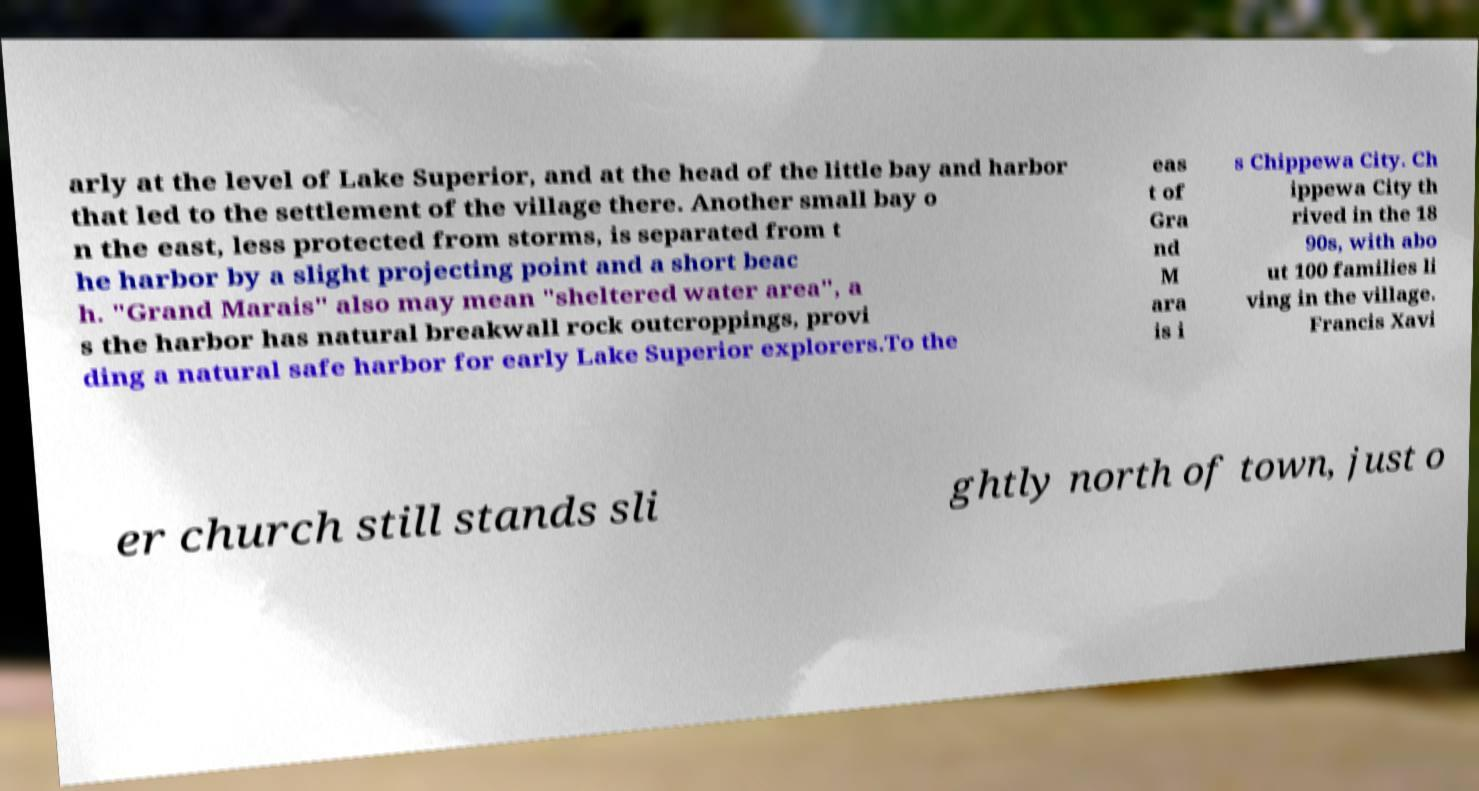Can you read and provide the text displayed in the image?This photo seems to have some interesting text. Can you extract and type it out for me? arly at the level of Lake Superior, and at the head of the little bay and harbor that led to the settlement of the village there. Another small bay o n the east, less protected from storms, is separated from t he harbor by a slight projecting point and a short beac h. "Grand Marais" also may mean "sheltered water area", a s the harbor has natural breakwall rock outcroppings, provi ding a natural safe harbor for early Lake Superior explorers.To the eas t of Gra nd M ara is i s Chippewa City. Ch ippewa City th rived in the 18 90s, with abo ut 100 families li ving in the village. Francis Xavi er church still stands sli ghtly north of town, just o 